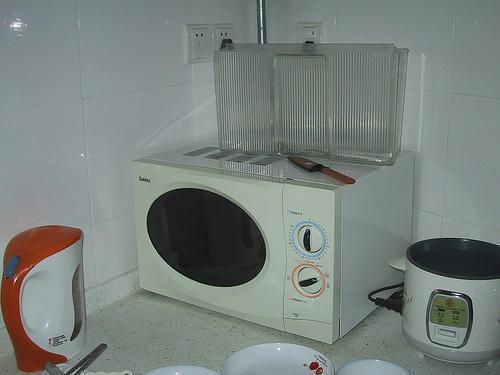How many knobs are on the microwave?
Give a very brief answer. 2. How many bowls can be seen?
Give a very brief answer. 3. How many outlets are on the walls?
Give a very brief answer. 3. 